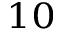<formula> <loc_0><loc_0><loc_500><loc_500>_ { 1 0 }</formula> 